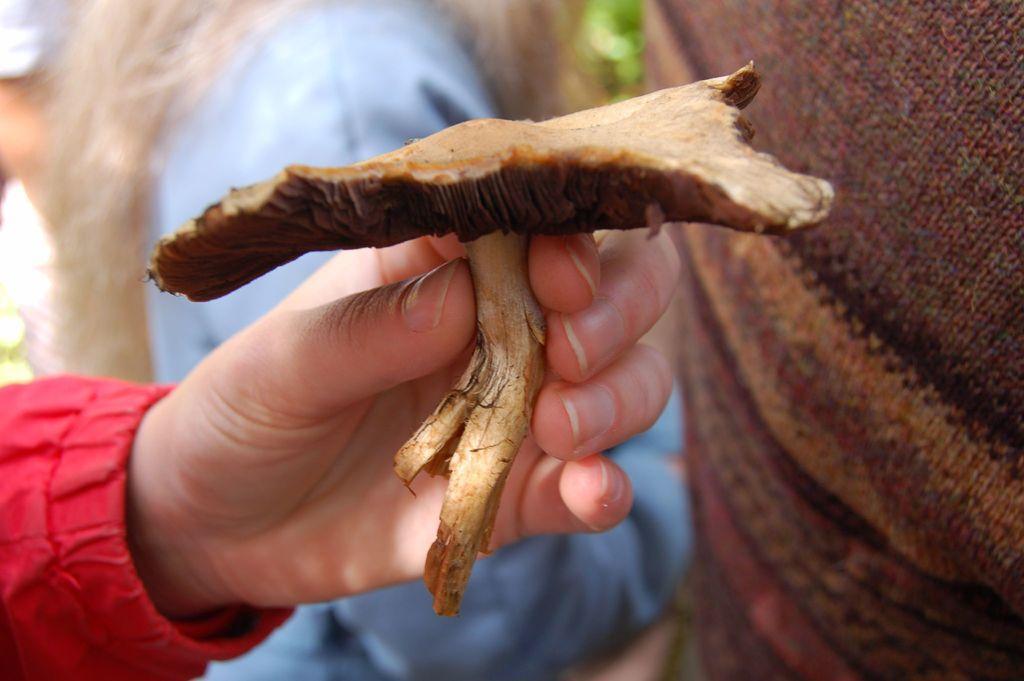How would you summarize this image in a sentence or two? In this image, we can see a human hand is holding some object. Background there is a blur view. Here we can see few clothes, human hair. 